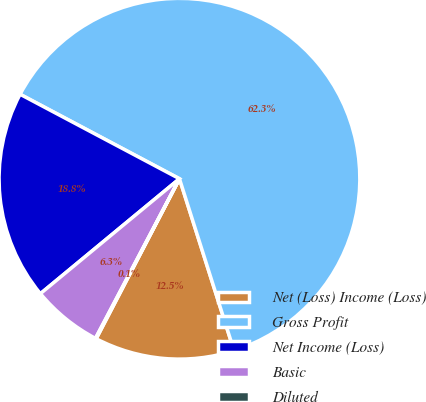Convert chart to OTSL. <chart><loc_0><loc_0><loc_500><loc_500><pie_chart><fcel>Net (Loss) Income (Loss)<fcel>Gross Profit<fcel>Net Income (Loss)<fcel>Basic<fcel>Diluted<nl><fcel>12.53%<fcel>62.35%<fcel>18.75%<fcel>6.3%<fcel>0.07%<nl></chart> 